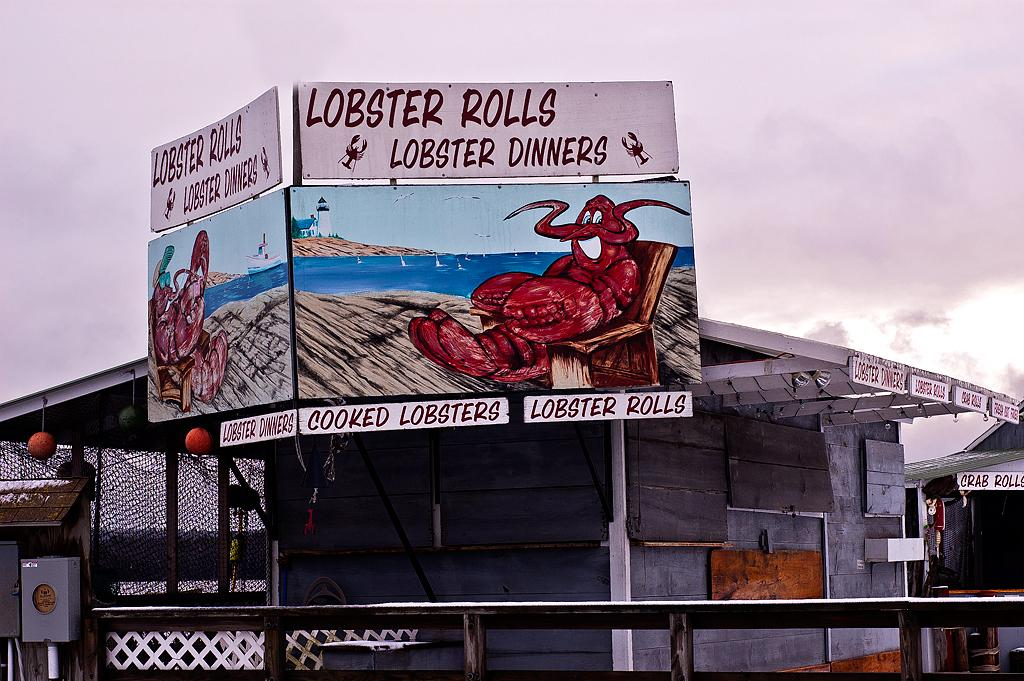Provide a one-sentence caption for the provided image. A billboard for lobster rolls and cooked lobster dinners. 